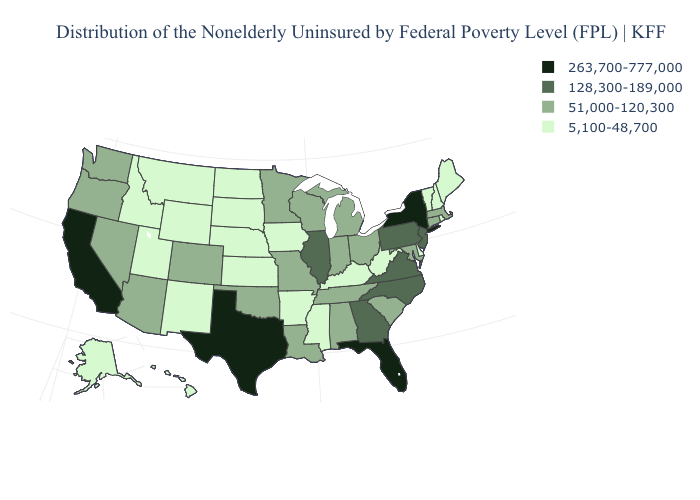What is the value of Arizona?
Be succinct. 51,000-120,300. What is the value of Texas?
Quick response, please. 263,700-777,000. Among the states that border New Mexico , does Arizona have the lowest value?
Concise answer only. No. What is the value of Texas?
Keep it brief. 263,700-777,000. What is the lowest value in the MidWest?
Keep it brief. 5,100-48,700. Among the states that border Oregon , which have the highest value?
Quick response, please. California. Which states have the lowest value in the USA?
Be succinct. Alaska, Arkansas, Delaware, Hawaii, Idaho, Iowa, Kansas, Kentucky, Maine, Mississippi, Montana, Nebraska, New Hampshire, New Mexico, North Dakota, Rhode Island, South Dakota, Utah, Vermont, West Virginia, Wyoming. Which states have the lowest value in the USA?
Quick response, please. Alaska, Arkansas, Delaware, Hawaii, Idaho, Iowa, Kansas, Kentucky, Maine, Mississippi, Montana, Nebraska, New Hampshire, New Mexico, North Dakota, Rhode Island, South Dakota, Utah, Vermont, West Virginia, Wyoming. What is the value of New Mexico?
Short answer required. 5,100-48,700. What is the value of Connecticut?
Be succinct. 51,000-120,300. Does Georgia have the lowest value in the USA?
Keep it brief. No. What is the value of Utah?
Give a very brief answer. 5,100-48,700. Does the map have missing data?
Answer briefly. No. Among the states that border Arkansas , which have the highest value?
Write a very short answer. Texas. Name the states that have a value in the range 128,300-189,000?
Short answer required. Georgia, Illinois, New Jersey, North Carolina, Pennsylvania, Virginia. 